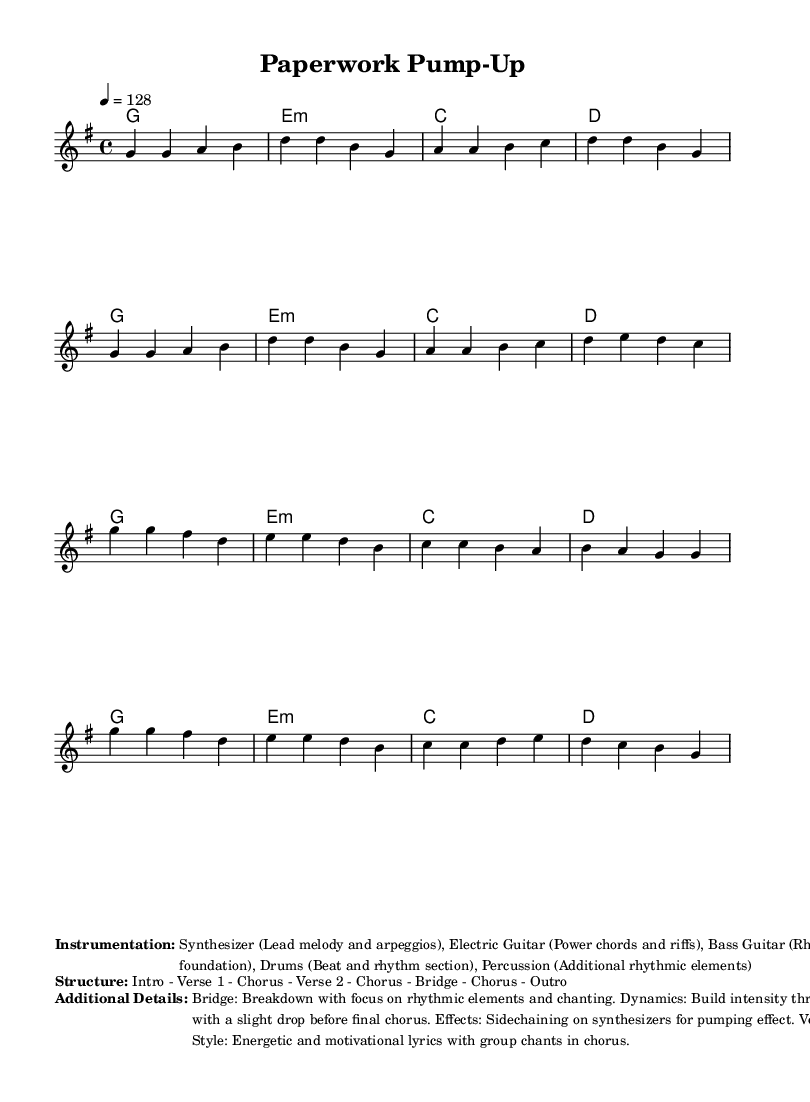What is the key signature of this music? The key signature is G major, which has one sharp (F#). This can be identified by looking at the key signature section at the beginning of the music sheet.
Answer: G major What is the time signature of this piece? The time signature is 4/4, which means there are four beats in each measure and the quarter note gets one beat. This is indicated at the beginning of the sheet music.
Answer: 4/4 What is the tempo marking of the music? The tempo marking is 128, which indicates that the piece should be played at 128 beats per minute. This is found in the tempo section at the start of the melody.
Answer: 128 How many verses are in the structure of this music? There are two verses in the structure, as indicated in the breakdown of the music layout provided. The structure explicitly states "Verse 1" and "Verse 2."
Answer: 2 What is the primary instrumentation for this piece? The primary instrumentation includes synthesizer, electric guitar, bass guitar, drums, and percussion. This is listed under the "Instrumentation" section in the markup area of the music sheet.
Answer: Synthesizer, Electric Guitar, Bass Guitar, Drums, Percussion What special effect is mentioned for synthesizers? The special effect mentioned for synthesizers is sidechaining, which is a technique used to create a pumping effect by lowering the volume when other sounds play. This is noted under "Additional Details."
Answer: Sidechaining What vocal style is indicated for the chorus? The vocal style indicated for the chorus is energetic and motivational, featuring group chants. This is described under the "Additional Details" section, highlighting the character of the vocals.
Answer: Energetic and motivational 